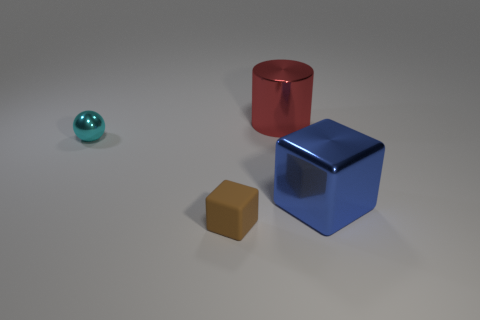Is there any other thing that has the same material as the brown object?
Give a very brief answer. No. Does the tiny thing that is behind the matte object have the same material as the red cylinder?
Your answer should be compact. Yes. What color is the other thing that is the same shape as the small brown object?
Provide a succinct answer. Blue. Do the large metallic object on the right side of the big cylinder and the small rubber object have the same color?
Your answer should be very brief. No. Are there any small brown rubber things behind the shiny cylinder?
Your answer should be compact. No. There is a thing that is both to the left of the big cylinder and right of the tiny cyan ball; what color is it?
Your response must be concise. Brown. There is a block that is in front of the block that is behind the small block; how big is it?
Your answer should be compact. Small. What number of cylinders are tiny things or large red shiny things?
Make the answer very short. 1. There is another shiny thing that is the same size as the red thing; what is its color?
Your response must be concise. Blue. There is a thing in front of the big metallic thing in front of the cylinder; what is its shape?
Offer a terse response. Cube. 